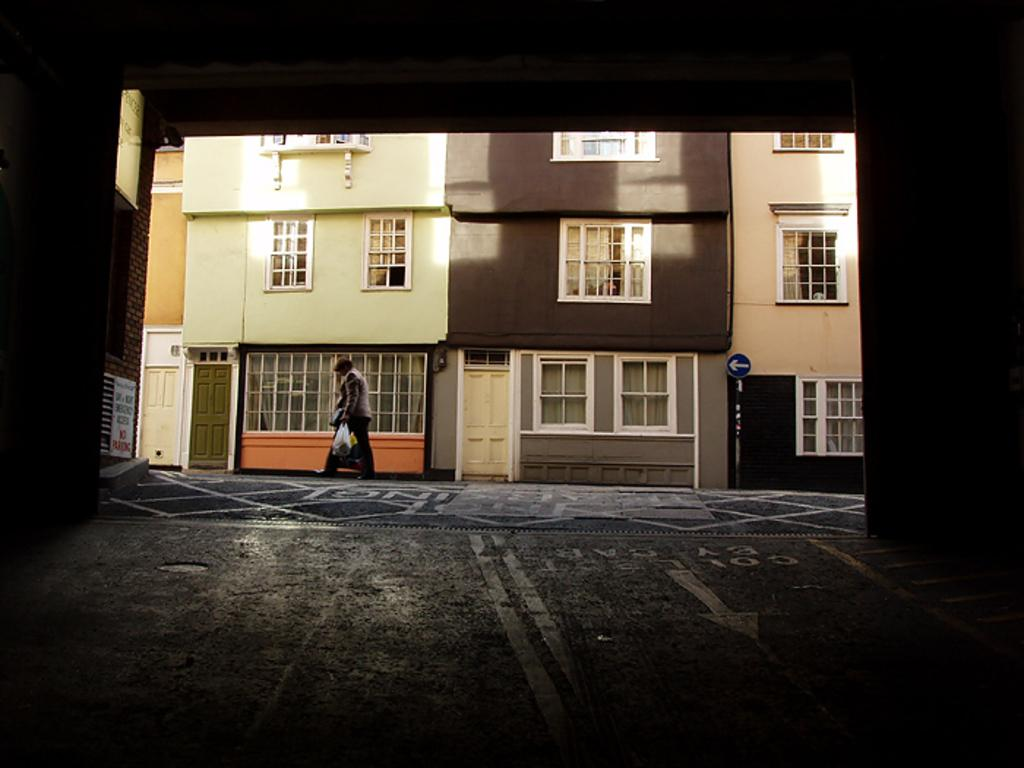What is the man in the image doing? The man is walking in the image. What can be seen in the background of the image? There is a building in the background of the image. What is located in the bottom right side of the image? There is a pole and a sign board in the bottom right side of the image. What type of butter is being spread on the cracker in the image? There is no butter or cracker present in the image. How many beans are visible on the man's plate in the image? There are no beans visible in the image. 